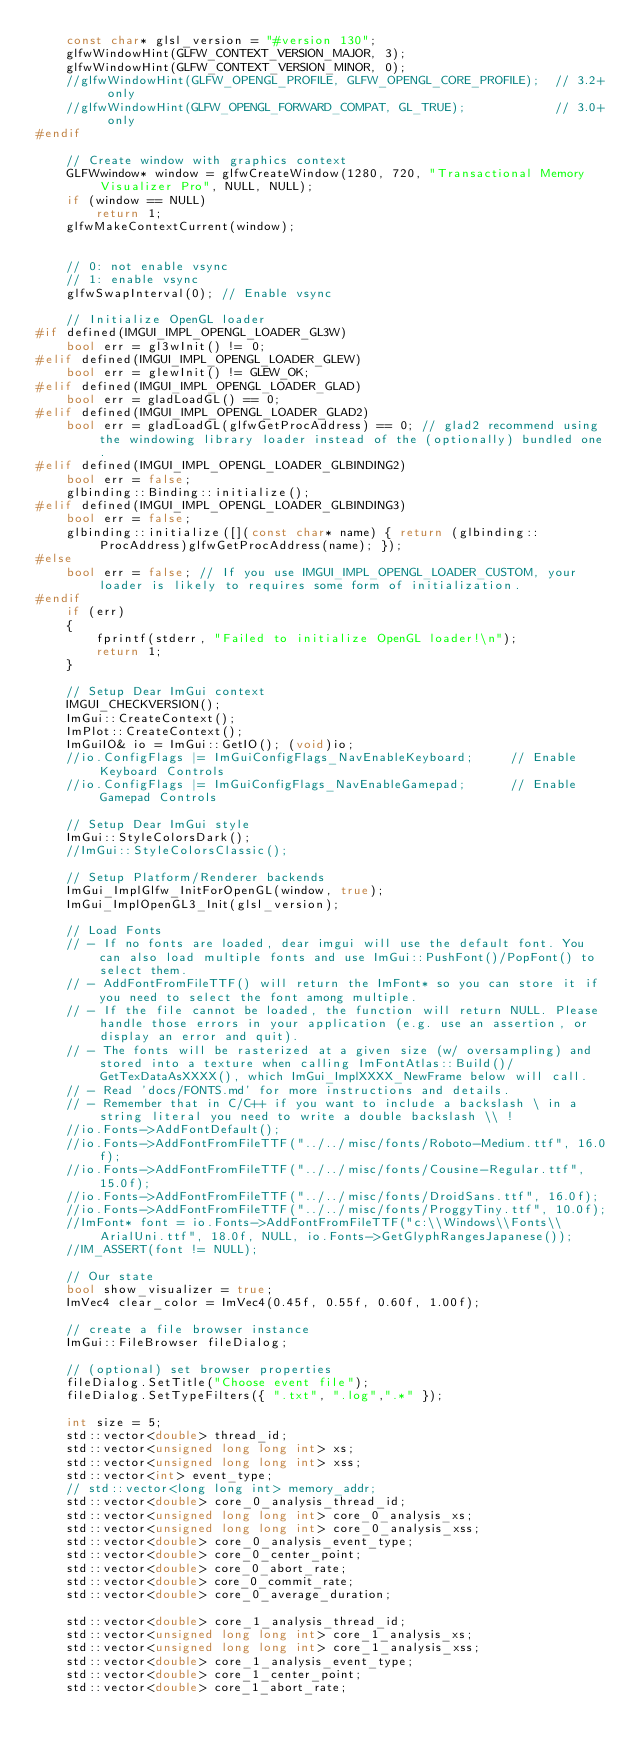Convert code to text. <code><loc_0><loc_0><loc_500><loc_500><_C++_>    const char* glsl_version = "#version 130";
    glfwWindowHint(GLFW_CONTEXT_VERSION_MAJOR, 3);
    glfwWindowHint(GLFW_CONTEXT_VERSION_MINOR, 0);
    //glfwWindowHint(GLFW_OPENGL_PROFILE, GLFW_OPENGL_CORE_PROFILE);  // 3.2+ only
    //glfwWindowHint(GLFW_OPENGL_FORWARD_COMPAT, GL_TRUE);            // 3.0+ only
#endif

    // Create window with graphics context
    GLFWwindow* window = glfwCreateWindow(1280, 720, "Transactional Memory Visualizer Pro", NULL, NULL);
    if (window == NULL)
        return 1;
    glfwMakeContextCurrent(window);


    // 0: not enable vsync
    // 1: enable vsync
    glfwSwapInterval(0); // Enable vsync

    // Initialize OpenGL loader
#if defined(IMGUI_IMPL_OPENGL_LOADER_GL3W)
    bool err = gl3wInit() != 0;
#elif defined(IMGUI_IMPL_OPENGL_LOADER_GLEW)
    bool err = glewInit() != GLEW_OK;
#elif defined(IMGUI_IMPL_OPENGL_LOADER_GLAD)
    bool err = gladLoadGL() == 0;
#elif defined(IMGUI_IMPL_OPENGL_LOADER_GLAD2)
    bool err = gladLoadGL(glfwGetProcAddress) == 0; // glad2 recommend using the windowing library loader instead of the (optionally) bundled one.
#elif defined(IMGUI_IMPL_OPENGL_LOADER_GLBINDING2)
    bool err = false;
    glbinding::Binding::initialize();
#elif defined(IMGUI_IMPL_OPENGL_LOADER_GLBINDING3)
    bool err = false;
    glbinding::initialize([](const char* name) { return (glbinding::ProcAddress)glfwGetProcAddress(name); });
#else
    bool err = false; // If you use IMGUI_IMPL_OPENGL_LOADER_CUSTOM, your loader is likely to requires some form of initialization.
#endif
    if (err)
    {
        fprintf(stderr, "Failed to initialize OpenGL loader!\n");
        return 1;
    }

    // Setup Dear ImGui context
    IMGUI_CHECKVERSION();
    ImGui::CreateContext();
    ImPlot::CreateContext();
    ImGuiIO& io = ImGui::GetIO(); (void)io;
    //io.ConfigFlags |= ImGuiConfigFlags_NavEnableKeyboard;     // Enable Keyboard Controls
    //io.ConfigFlags |= ImGuiConfigFlags_NavEnableGamepad;      // Enable Gamepad Controls

    // Setup Dear ImGui style
    ImGui::StyleColorsDark();
    //ImGui::StyleColorsClassic();
    
    // Setup Platform/Renderer backends
    ImGui_ImplGlfw_InitForOpenGL(window, true);
    ImGui_ImplOpenGL3_Init(glsl_version);

    // Load Fonts
    // - If no fonts are loaded, dear imgui will use the default font. You can also load multiple fonts and use ImGui::PushFont()/PopFont() to select them.
    // - AddFontFromFileTTF() will return the ImFont* so you can store it if you need to select the font among multiple.
    // - If the file cannot be loaded, the function will return NULL. Please handle those errors in your application (e.g. use an assertion, or display an error and quit).
    // - The fonts will be rasterized at a given size (w/ oversampling) and stored into a texture when calling ImFontAtlas::Build()/GetTexDataAsXXXX(), which ImGui_ImplXXXX_NewFrame below will call.
    // - Read 'docs/FONTS.md' for more instructions and details.
    // - Remember that in C/C++ if you want to include a backslash \ in a string literal you need to write a double backslash \\ !
    //io.Fonts->AddFontDefault();
    //io.Fonts->AddFontFromFileTTF("../../misc/fonts/Roboto-Medium.ttf", 16.0f);
    //io.Fonts->AddFontFromFileTTF("../../misc/fonts/Cousine-Regular.ttf", 15.0f);
    //io.Fonts->AddFontFromFileTTF("../../misc/fonts/DroidSans.ttf", 16.0f);
    //io.Fonts->AddFontFromFileTTF("../../misc/fonts/ProggyTiny.ttf", 10.0f);
    //ImFont* font = io.Fonts->AddFontFromFileTTF("c:\\Windows\\Fonts\\ArialUni.ttf", 18.0f, NULL, io.Fonts->GetGlyphRangesJapanese());
    //IM_ASSERT(font != NULL);

    // Our state
    bool show_visualizer = true;
    ImVec4 clear_color = ImVec4(0.45f, 0.55f, 0.60f, 1.00f);

    // create a file browser instance
    ImGui::FileBrowser fileDialog;
    
    // (optional) set browser properties
    fileDialog.SetTitle("Choose event file");
    fileDialog.SetTypeFilters({ ".txt", ".log",".*" });

    int size = 5;
    std::vector<double> thread_id;
    std::vector<unsigned long long int> xs;
    std::vector<unsigned long long int> xss;
    std::vector<int> event_type;
    // std::vector<long long int> memory_addr;
    std::vector<double> core_0_analysis_thread_id;
    std::vector<unsigned long long int> core_0_analysis_xs;
    std::vector<unsigned long long int> core_0_analysis_xss;
    std::vector<double> core_0_analysis_event_type;
    std::vector<double> core_0_center_point;
    std::vector<double> core_0_abort_rate;
    std::vector<double> core_0_commit_rate;
    std::vector<double> core_0_average_duration;

    std::vector<double> core_1_analysis_thread_id;
    std::vector<unsigned long long int> core_1_analysis_xs;
    std::vector<unsigned long long int> core_1_analysis_xss;
    std::vector<double> core_1_analysis_event_type;
    std::vector<double> core_1_center_point;
    std::vector<double> core_1_abort_rate;</code> 